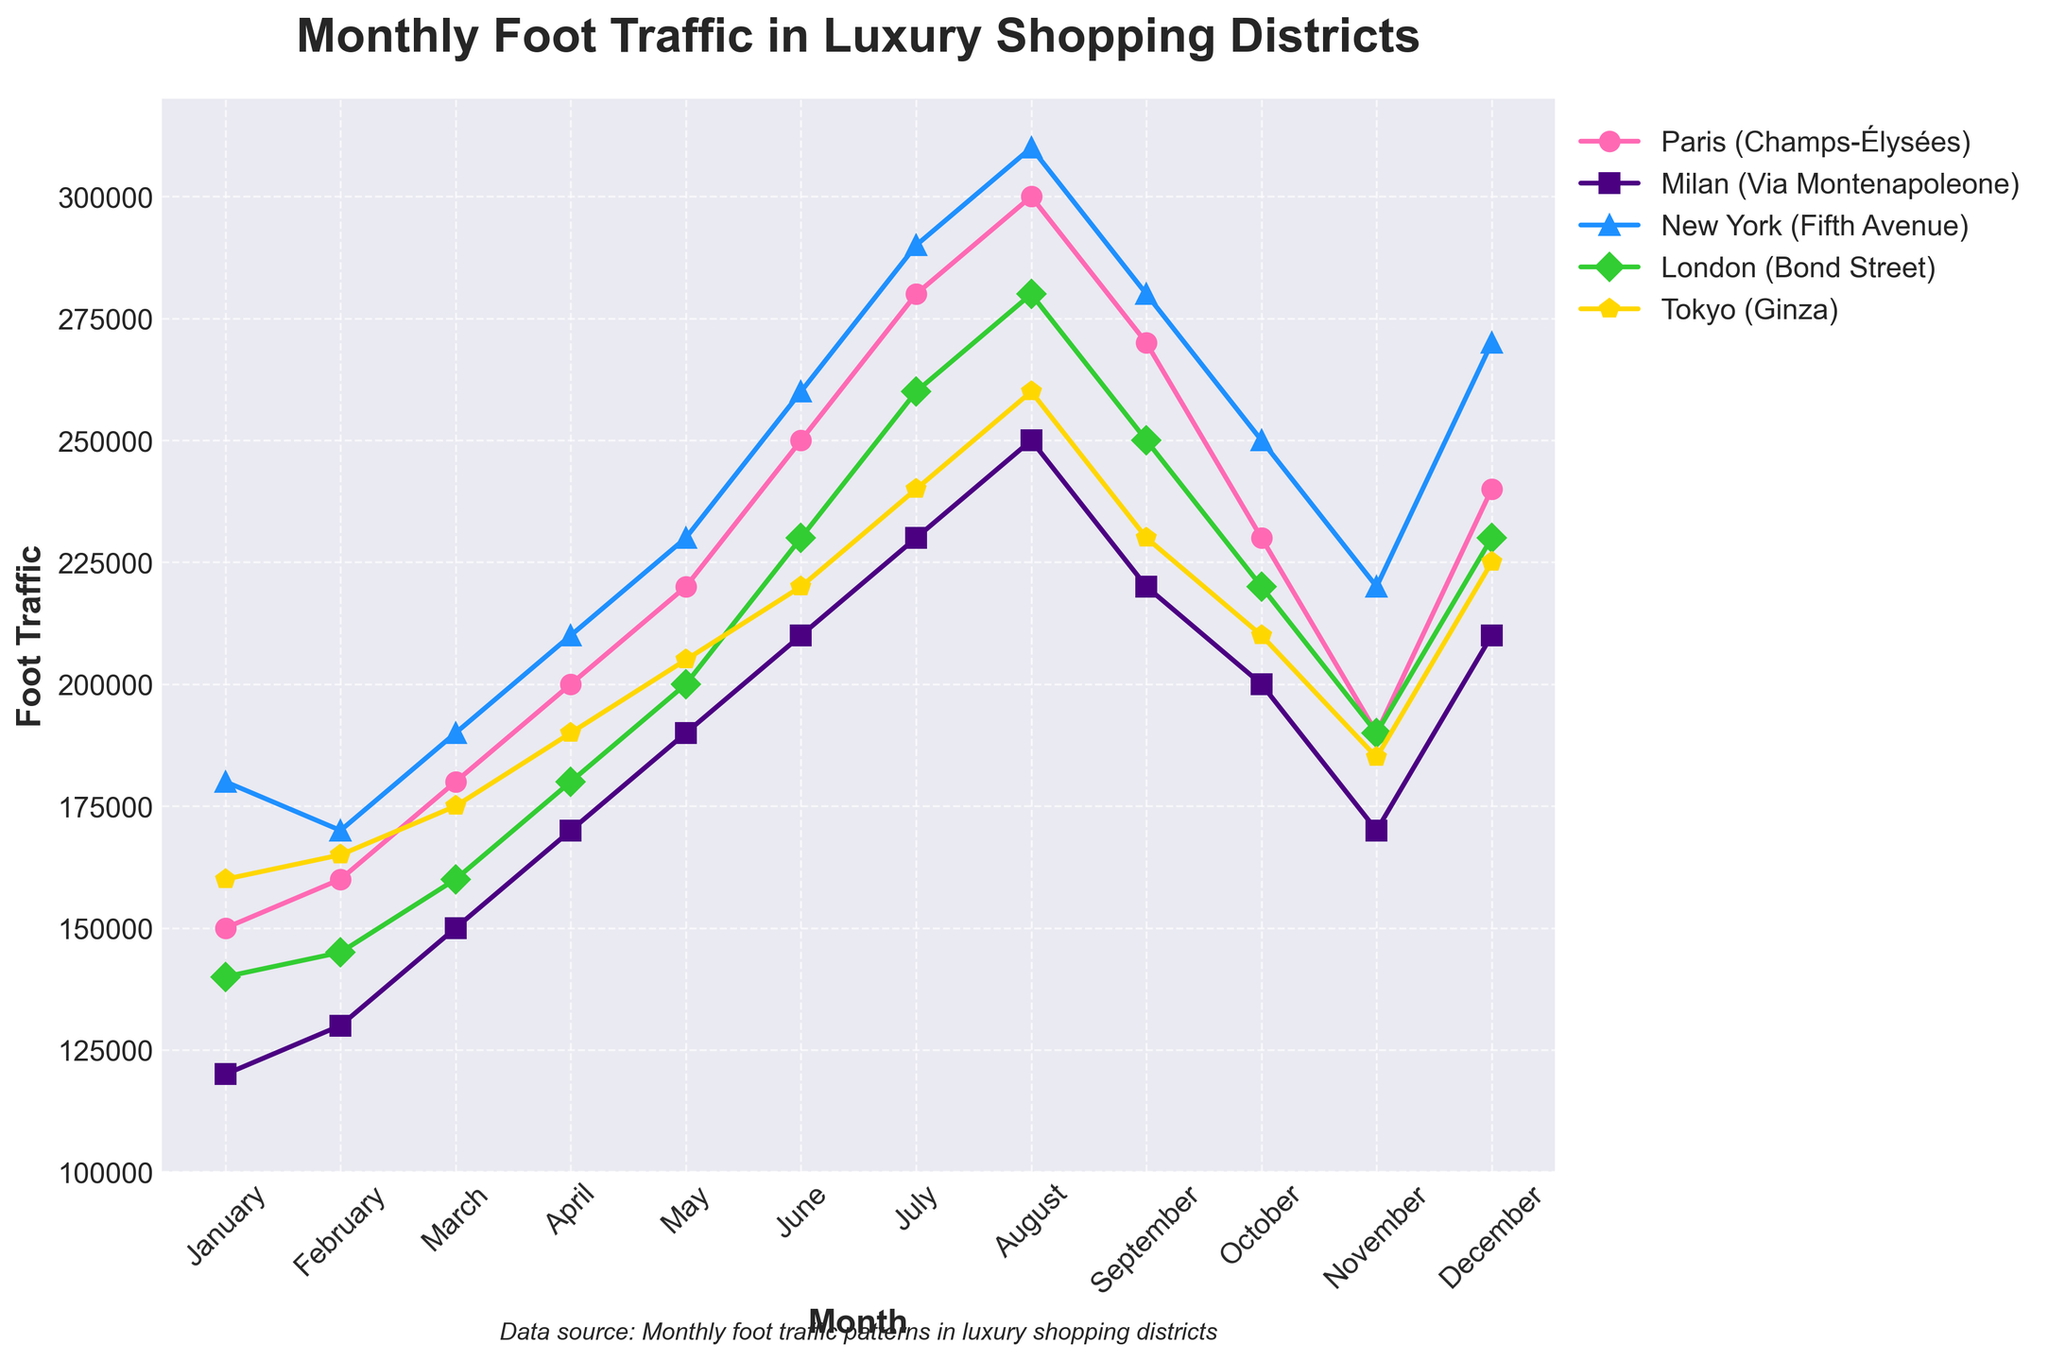Which city had the highest foot traffic in August? The line chart indicates the foot traffic for each city over twelve months. By examining the data points for August, it is evident that New York (Fifth Avenue) has the highest foot traffic.
Answer: New York (Fifth Avenue) What is the average foot traffic in Paris (Champs-Élysées) over the year? First, sum all monthly foot traffic values for Paris. Total foot traffic = 150000 + 160000 + 180000 + 200000 + 220000 + 250000 + 280000 + 300000 + 270000 + 230000 + 190000 + 240000 = 2670000. Then, divide by the number of months (12). Average = 2670000 / 12 = 222500
Answer: 222500 Which month shows the lowest foot traffic for Milan (Via Montenapoleone)? Reviewing the data points for Milan (Via Montenapoleone), the lowest value occurs in January with 120000 foot traffic.
Answer: January How does the foot traffic in Tokyo (Ginza) compare between April and October? The foot traffic in Tokyo (Ginza) is 190000 in April and 210000 in October. By comparing these values, we see that October's foot traffic is higher than April's.
Answer: October In which city does the foot traffic decrease steadily from August to November? The line chart indicates the slope of each city's foot traffic from August to November. Milan (Via Montenapoleone) decreases steadily from 250000 in August to 220000, 200000, and 170000 in September, October, and November, respectively.
Answer: Milan (Via Montenapoleone) What is the total foot traffic for all cities combined in June? Summing the foot traffic values for each city in June gives: 250000 (Paris) + 210000 (Milan) + 260000 (New York) + 230000 (London) + 220000 (Tokyo) = 1170000.
Answer: 1170000 Which city's foot traffic peaks in July, and what is the value? By examining the peaks for each city, New York (Fifth Avenue) reaches its highest in July with 290000.
Answer: New York (Fifth Avenue), 290000 Is there a month where all cities experience an increase in foot traffic compared to the previous month? Analyzing the trend lines, all cities show an increase from March to April. Paris goes from 180000 to 200000, Milan from 150000 to 170000, New York from 190000 to 210000, London from 160000 to 180000, and Tokyo from 175000 to 190000.
Answer: April What is the difference in foot traffic between the highest and lowest month for London (Bond Street)? London’s highest foot traffic is in August with 280000 and its lowest in January with 140000. The difference is 280000 - 140000 = 140000.
Answer: 140000 Which month shows the smallest variation in foot traffic among all cities? The smallest variation, calculated as the difference between the highest and lowest foot traffic in a month, appears in February. Paris: 160000, Milan: 130000, New York: 170000, London: 145000, Tokyo: 165000. The variation here is 170000 - 130000 = 40000.
Answer: February 